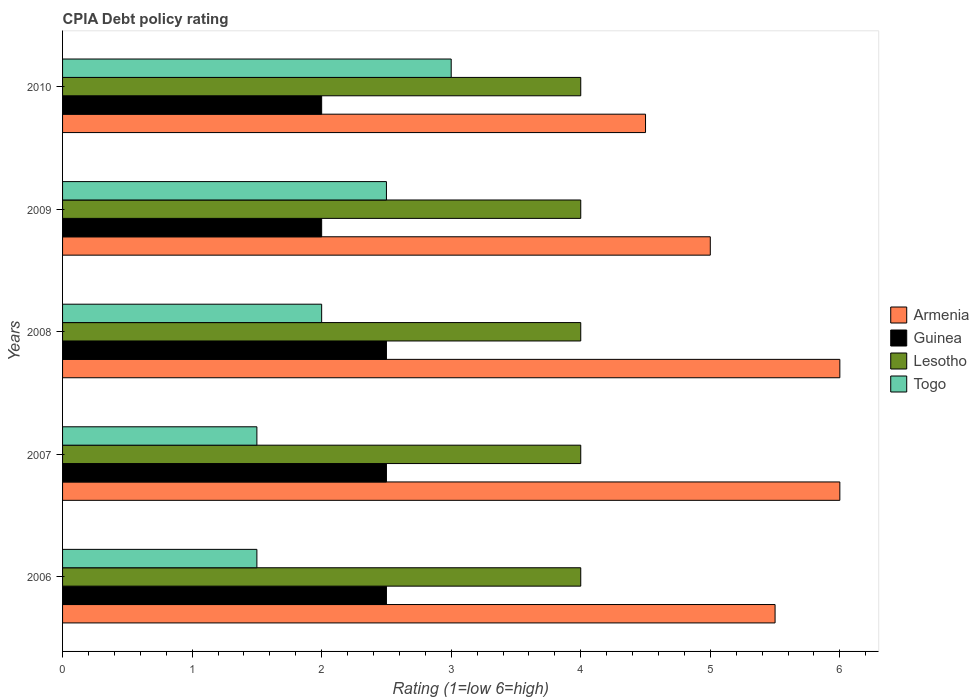Are the number of bars per tick equal to the number of legend labels?
Your response must be concise. Yes. Are the number of bars on each tick of the Y-axis equal?
Make the answer very short. Yes. How many bars are there on the 5th tick from the bottom?
Provide a short and direct response. 4. In how many cases, is the number of bars for a given year not equal to the number of legend labels?
Provide a succinct answer. 0. In which year was the CPIA rating in Guinea maximum?
Keep it short and to the point. 2006. What is the total CPIA rating in Guinea in the graph?
Offer a terse response. 11.5. What is the difference between the CPIA rating in Togo in 2006 and that in 2010?
Provide a succinct answer. -1.5. What is the average CPIA rating in Guinea per year?
Your answer should be very brief. 2.3. Is the sum of the CPIA rating in Armenia in 2006 and 2009 greater than the maximum CPIA rating in Togo across all years?
Your answer should be very brief. Yes. Is it the case that in every year, the sum of the CPIA rating in Lesotho and CPIA rating in Guinea is greater than the sum of CPIA rating in Armenia and CPIA rating in Togo?
Provide a short and direct response. No. What does the 4th bar from the top in 2006 represents?
Keep it short and to the point. Armenia. What does the 2nd bar from the bottom in 2009 represents?
Make the answer very short. Guinea. Are all the bars in the graph horizontal?
Ensure brevity in your answer.  Yes. What is the difference between two consecutive major ticks on the X-axis?
Offer a very short reply. 1. Are the values on the major ticks of X-axis written in scientific E-notation?
Your answer should be very brief. No. Does the graph contain any zero values?
Give a very brief answer. No. How many legend labels are there?
Offer a terse response. 4. How are the legend labels stacked?
Ensure brevity in your answer.  Vertical. What is the title of the graph?
Your answer should be very brief. CPIA Debt policy rating. Does "Afghanistan" appear as one of the legend labels in the graph?
Your answer should be compact. No. What is the label or title of the X-axis?
Your response must be concise. Rating (1=low 6=high). What is the label or title of the Y-axis?
Your response must be concise. Years. What is the Rating (1=low 6=high) in Guinea in 2006?
Your response must be concise. 2.5. What is the Rating (1=low 6=high) of Lesotho in 2006?
Your response must be concise. 4. What is the Rating (1=low 6=high) of Togo in 2006?
Your answer should be compact. 1.5. What is the Rating (1=low 6=high) of Guinea in 2007?
Give a very brief answer. 2.5. What is the Rating (1=low 6=high) of Lesotho in 2007?
Your answer should be very brief. 4. What is the Rating (1=low 6=high) of Togo in 2007?
Keep it short and to the point. 1.5. What is the Rating (1=low 6=high) in Armenia in 2008?
Provide a succinct answer. 6. What is the Rating (1=low 6=high) in Lesotho in 2008?
Your answer should be compact. 4. What is the Rating (1=low 6=high) of Togo in 2008?
Give a very brief answer. 2. What is the Rating (1=low 6=high) of Togo in 2009?
Keep it short and to the point. 2.5. What is the Rating (1=low 6=high) of Lesotho in 2010?
Provide a short and direct response. 4. Across all years, what is the maximum Rating (1=low 6=high) of Armenia?
Offer a terse response. 6. Across all years, what is the maximum Rating (1=low 6=high) in Lesotho?
Offer a terse response. 4. Across all years, what is the maximum Rating (1=low 6=high) of Togo?
Offer a very short reply. 3. Across all years, what is the minimum Rating (1=low 6=high) in Armenia?
Provide a short and direct response. 4.5. Across all years, what is the minimum Rating (1=low 6=high) of Lesotho?
Your response must be concise. 4. Across all years, what is the minimum Rating (1=low 6=high) of Togo?
Give a very brief answer. 1.5. What is the total Rating (1=low 6=high) of Guinea in the graph?
Your answer should be very brief. 11.5. What is the total Rating (1=low 6=high) in Lesotho in the graph?
Your response must be concise. 20. What is the difference between the Rating (1=low 6=high) in Lesotho in 2006 and that in 2007?
Ensure brevity in your answer.  0. What is the difference between the Rating (1=low 6=high) of Armenia in 2006 and that in 2008?
Keep it short and to the point. -0.5. What is the difference between the Rating (1=low 6=high) in Lesotho in 2006 and that in 2008?
Your answer should be compact. 0. What is the difference between the Rating (1=low 6=high) of Togo in 2006 and that in 2009?
Keep it short and to the point. -1. What is the difference between the Rating (1=low 6=high) in Armenia in 2006 and that in 2010?
Make the answer very short. 1. What is the difference between the Rating (1=low 6=high) of Lesotho in 2006 and that in 2010?
Provide a short and direct response. 0. What is the difference between the Rating (1=low 6=high) in Togo in 2006 and that in 2010?
Offer a terse response. -1.5. What is the difference between the Rating (1=low 6=high) in Guinea in 2007 and that in 2008?
Your answer should be compact. 0. What is the difference between the Rating (1=low 6=high) in Armenia in 2007 and that in 2009?
Provide a short and direct response. 1. What is the difference between the Rating (1=low 6=high) of Lesotho in 2007 and that in 2009?
Provide a short and direct response. 0. What is the difference between the Rating (1=low 6=high) of Togo in 2007 and that in 2009?
Provide a succinct answer. -1. What is the difference between the Rating (1=low 6=high) of Guinea in 2007 and that in 2010?
Offer a very short reply. 0.5. What is the difference between the Rating (1=low 6=high) of Lesotho in 2007 and that in 2010?
Make the answer very short. 0. What is the difference between the Rating (1=low 6=high) in Togo in 2007 and that in 2010?
Your answer should be very brief. -1.5. What is the difference between the Rating (1=low 6=high) of Armenia in 2008 and that in 2009?
Offer a very short reply. 1. What is the difference between the Rating (1=low 6=high) of Guinea in 2008 and that in 2009?
Give a very brief answer. 0.5. What is the difference between the Rating (1=low 6=high) in Togo in 2008 and that in 2009?
Make the answer very short. -0.5. What is the difference between the Rating (1=low 6=high) in Lesotho in 2008 and that in 2010?
Keep it short and to the point. 0. What is the difference between the Rating (1=low 6=high) of Togo in 2008 and that in 2010?
Ensure brevity in your answer.  -1. What is the difference between the Rating (1=low 6=high) in Armenia in 2009 and that in 2010?
Your response must be concise. 0.5. What is the difference between the Rating (1=low 6=high) of Guinea in 2009 and that in 2010?
Give a very brief answer. 0. What is the difference between the Rating (1=low 6=high) of Togo in 2009 and that in 2010?
Your answer should be very brief. -0.5. What is the difference between the Rating (1=low 6=high) of Armenia in 2006 and the Rating (1=low 6=high) of Lesotho in 2007?
Offer a terse response. 1.5. What is the difference between the Rating (1=low 6=high) in Guinea in 2006 and the Rating (1=low 6=high) in Togo in 2007?
Keep it short and to the point. 1. What is the difference between the Rating (1=low 6=high) in Armenia in 2006 and the Rating (1=low 6=high) in Togo in 2008?
Give a very brief answer. 3.5. What is the difference between the Rating (1=low 6=high) of Guinea in 2006 and the Rating (1=low 6=high) of Togo in 2008?
Give a very brief answer. 0.5. What is the difference between the Rating (1=low 6=high) in Lesotho in 2006 and the Rating (1=low 6=high) in Togo in 2008?
Provide a succinct answer. 2. What is the difference between the Rating (1=low 6=high) of Armenia in 2006 and the Rating (1=low 6=high) of Lesotho in 2009?
Offer a terse response. 1.5. What is the difference between the Rating (1=low 6=high) in Armenia in 2006 and the Rating (1=low 6=high) in Guinea in 2010?
Offer a very short reply. 3.5. What is the difference between the Rating (1=low 6=high) of Armenia in 2006 and the Rating (1=low 6=high) of Lesotho in 2010?
Your answer should be very brief. 1.5. What is the difference between the Rating (1=low 6=high) of Armenia in 2006 and the Rating (1=low 6=high) of Togo in 2010?
Your answer should be compact. 2.5. What is the difference between the Rating (1=low 6=high) in Guinea in 2006 and the Rating (1=low 6=high) in Togo in 2010?
Give a very brief answer. -0.5. What is the difference between the Rating (1=low 6=high) in Lesotho in 2006 and the Rating (1=low 6=high) in Togo in 2010?
Your response must be concise. 1. What is the difference between the Rating (1=low 6=high) of Armenia in 2007 and the Rating (1=low 6=high) of Guinea in 2008?
Ensure brevity in your answer.  3.5. What is the difference between the Rating (1=low 6=high) of Armenia in 2007 and the Rating (1=low 6=high) of Lesotho in 2008?
Your response must be concise. 2. What is the difference between the Rating (1=low 6=high) of Armenia in 2007 and the Rating (1=low 6=high) of Togo in 2008?
Offer a very short reply. 4. What is the difference between the Rating (1=low 6=high) in Armenia in 2007 and the Rating (1=low 6=high) in Guinea in 2009?
Your answer should be very brief. 4. What is the difference between the Rating (1=low 6=high) in Armenia in 2007 and the Rating (1=low 6=high) in Togo in 2009?
Your answer should be very brief. 3.5. What is the difference between the Rating (1=low 6=high) in Guinea in 2007 and the Rating (1=low 6=high) in Togo in 2009?
Give a very brief answer. 0. What is the difference between the Rating (1=low 6=high) in Lesotho in 2007 and the Rating (1=low 6=high) in Togo in 2009?
Keep it short and to the point. 1.5. What is the difference between the Rating (1=low 6=high) of Armenia in 2007 and the Rating (1=low 6=high) of Guinea in 2010?
Provide a short and direct response. 4. What is the difference between the Rating (1=low 6=high) in Lesotho in 2007 and the Rating (1=low 6=high) in Togo in 2010?
Your answer should be compact. 1. What is the difference between the Rating (1=low 6=high) of Armenia in 2008 and the Rating (1=low 6=high) of Togo in 2009?
Ensure brevity in your answer.  3.5. What is the difference between the Rating (1=low 6=high) in Guinea in 2008 and the Rating (1=low 6=high) in Lesotho in 2009?
Your response must be concise. -1.5. What is the difference between the Rating (1=low 6=high) of Guinea in 2008 and the Rating (1=low 6=high) of Togo in 2009?
Your answer should be compact. 0. What is the difference between the Rating (1=low 6=high) of Lesotho in 2008 and the Rating (1=low 6=high) of Togo in 2009?
Provide a short and direct response. 1.5. What is the difference between the Rating (1=low 6=high) of Armenia in 2008 and the Rating (1=low 6=high) of Lesotho in 2010?
Ensure brevity in your answer.  2. What is the difference between the Rating (1=low 6=high) in Armenia in 2008 and the Rating (1=low 6=high) in Togo in 2010?
Keep it short and to the point. 3. What is the difference between the Rating (1=low 6=high) of Guinea in 2008 and the Rating (1=low 6=high) of Lesotho in 2010?
Your answer should be very brief. -1.5. What is the difference between the Rating (1=low 6=high) in Armenia in 2009 and the Rating (1=low 6=high) in Lesotho in 2010?
Provide a short and direct response. 1. What is the difference between the Rating (1=low 6=high) in Armenia in 2009 and the Rating (1=low 6=high) in Togo in 2010?
Give a very brief answer. 2. What is the difference between the Rating (1=low 6=high) in Lesotho in 2009 and the Rating (1=low 6=high) in Togo in 2010?
Offer a terse response. 1. What is the average Rating (1=low 6=high) of Armenia per year?
Ensure brevity in your answer.  5.4. What is the average Rating (1=low 6=high) in Guinea per year?
Your response must be concise. 2.3. What is the average Rating (1=low 6=high) of Lesotho per year?
Ensure brevity in your answer.  4. In the year 2006, what is the difference between the Rating (1=low 6=high) of Armenia and Rating (1=low 6=high) of Lesotho?
Ensure brevity in your answer.  1.5. In the year 2006, what is the difference between the Rating (1=low 6=high) in Armenia and Rating (1=low 6=high) in Togo?
Your answer should be very brief. 4. In the year 2007, what is the difference between the Rating (1=low 6=high) in Armenia and Rating (1=low 6=high) in Guinea?
Offer a terse response. 3.5. In the year 2007, what is the difference between the Rating (1=low 6=high) in Armenia and Rating (1=low 6=high) in Lesotho?
Provide a short and direct response. 2. In the year 2007, what is the difference between the Rating (1=low 6=high) in Armenia and Rating (1=low 6=high) in Togo?
Offer a very short reply. 4.5. In the year 2008, what is the difference between the Rating (1=low 6=high) in Armenia and Rating (1=low 6=high) in Guinea?
Offer a terse response. 3.5. In the year 2008, what is the difference between the Rating (1=low 6=high) in Guinea and Rating (1=low 6=high) in Togo?
Your answer should be very brief. 0.5. In the year 2009, what is the difference between the Rating (1=low 6=high) in Armenia and Rating (1=low 6=high) in Lesotho?
Keep it short and to the point. 1. In the year 2009, what is the difference between the Rating (1=low 6=high) in Armenia and Rating (1=low 6=high) in Togo?
Your response must be concise. 2.5. In the year 2009, what is the difference between the Rating (1=low 6=high) of Lesotho and Rating (1=low 6=high) of Togo?
Provide a succinct answer. 1.5. In the year 2010, what is the difference between the Rating (1=low 6=high) in Armenia and Rating (1=low 6=high) in Togo?
Offer a terse response. 1.5. In the year 2010, what is the difference between the Rating (1=low 6=high) of Guinea and Rating (1=low 6=high) of Togo?
Give a very brief answer. -1. What is the ratio of the Rating (1=low 6=high) in Armenia in 2006 to that in 2007?
Keep it short and to the point. 0.92. What is the ratio of the Rating (1=low 6=high) of Togo in 2006 to that in 2007?
Ensure brevity in your answer.  1. What is the ratio of the Rating (1=low 6=high) of Lesotho in 2006 to that in 2008?
Your answer should be very brief. 1. What is the ratio of the Rating (1=low 6=high) in Togo in 2006 to that in 2008?
Your response must be concise. 0.75. What is the ratio of the Rating (1=low 6=high) of Lesotho in 2006 to that in 2009?
Your answer should be compact. 1. What is the ratio of the Rating (1=low 6=high) of Armenia in 2006 to that in 2010?
Provide a succinct answer. 1.22. What is the ratio of the Rating (1=low 6=high) in Lesotho in 2006 to that in 2010?
Ensure brevity in your answer.  1. What is the ratio of the Rating (1=low 6=high) of Togo in 2006 to that in 2010?
Your answer should be very brief. 0.5. What is the ratio of the Rating (1=low 6=high) of Lesotho in 2007 to that in 2009?
Your answer should be compact. 1. What is the ratio of the Rating (1=low 6=high) in Guinea in 2007 to that in 2010?
Provide a short and direct response. 1.25. What is the ratio of the Rating (1=low 6=high) in Lesotho in 2007 to that in 2010?
Provide a succinct answer. 1. What is the ratio of the Rating (1=low 6=high) in Togo in 2007 to that in 2010?
Ensure brevity in your answer.  0.5. What is the ratio of the Rating (1=low 6=high) in Guinea in 2008 to that in 2009?
Your response must be concise. 1.25. What is the ratio of the Rating (1=low 6=high) in Lesotho in 2008 to that in 2009?
Ensure brevity in your answer.  1. What is the ratio of the Rating (1=low 6=high) of Armenia in 2008 to that in 2010?
Give a very brief answer. 1.33. What is the ratio of the Rating (1=low 6=high) in Armenia in 2009 to that in 2010?
Your response must be concise. 1.11. What is the ratio of the Rating (1=low 6=high) of Togo in 2009 to that in 2010?
Make the answer very short. 0.83. What is the difference between the highest and the second highest Rating (1=low 6=high) of Armenia?
Keep it short and to the point. 0. What is the difference between the highest and the second highest Rating (1=low 6=high) in Lesotho?
Offer a very short reply. 0. What is the difference between the highest and the lowest Rating (1=low 6=high) in Guinea?
Offer a very short reply. 0.5. What is the difference between the highest and the lowest Rating (1=low 6=high) of Lesotho?
Offer a very short reply. 0. 